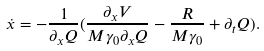<formula> <loc_0><loc_0><loc_500><loc_500>\dot { x } = - \frac { 1 } { \partial _ { x } Q } ( \frac { \partial _ { x } V } { M \gamma _ { 0 } \partial _ { x } Q } - \frac { R } { M \gamma _ { 0 } } + \partial _ { t } Q ) .</formula> 